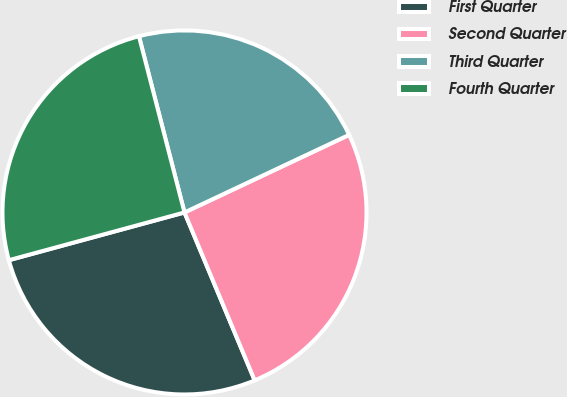Convert chart. <chart><loc_0><loc_0><loc_500><loc_500><pie_chart><fcel>First Quarter<fcel>Second Quarter<fcel>Third Quarter<fcel>Fourth Quarter<nl><fcel>27.08%<fcel>25.71%<fcel>22.02%<fcel>25.2%<nl></chart> 